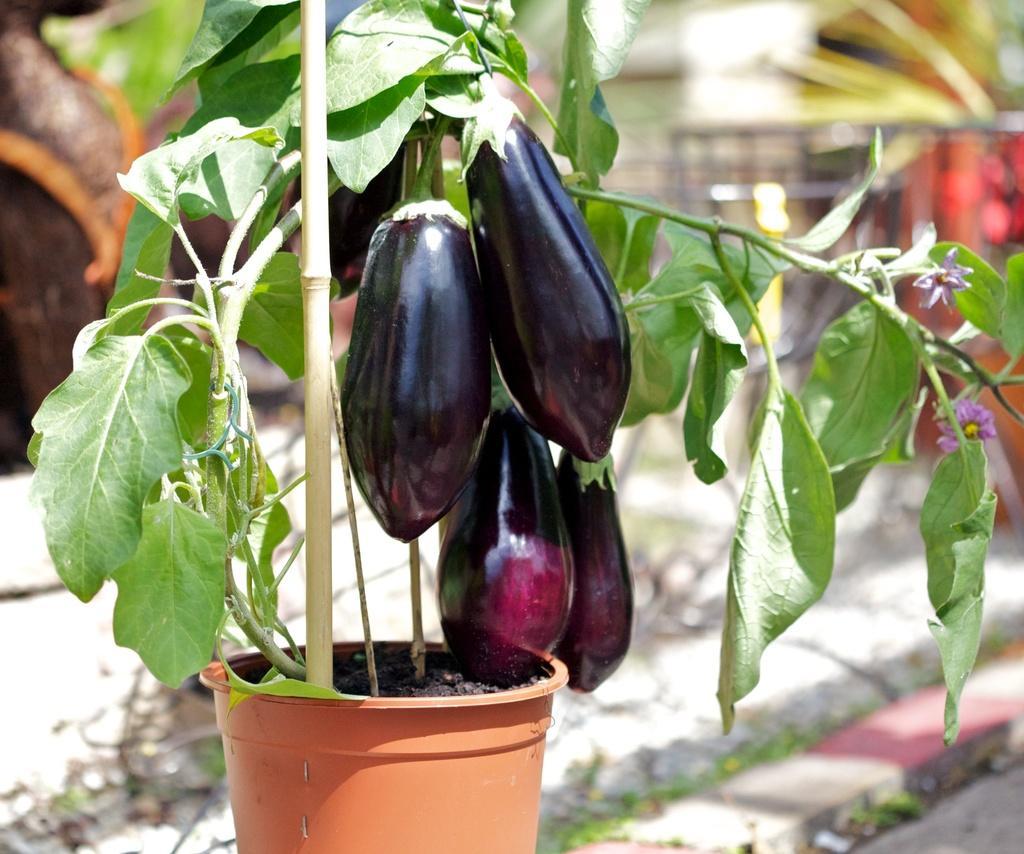Can you describe this image briefly? In this image in the foreground I can see a brinjal plant and background is blurred. 